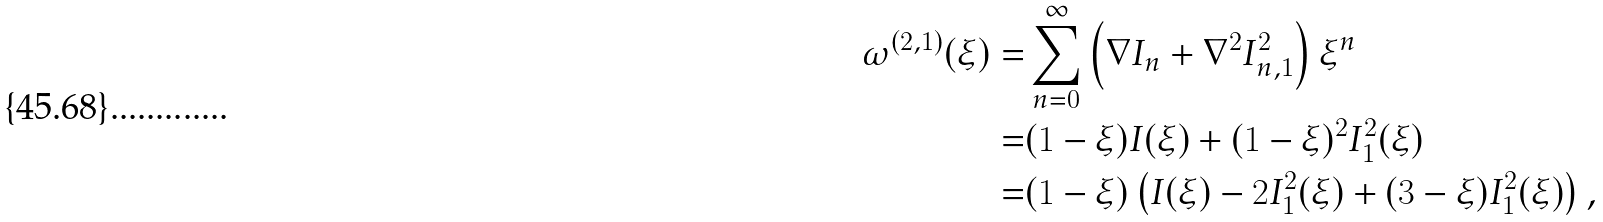Convert formula to latex. <formula><loc_0><loc_0><loc_500><loc_500>\omega ^ { ( 2 , 1 ) } ( \xi ) = & \sum _ { n = 0 } ^ { \infty } \left ( \nabla I _ { n } + \nabla ^ { 2 } I _ { n , 1 } ^ { 2 } \right ) \xi ^ { n } \\ = & ( 1 - \xi ) I ( \xi ) + ( 1 - \xi ) ^ { 2 } I _ { 1 } ^ { 2 } ( \xi ) \\ = & ( 1 - \xi ) \left ( I ( \xi ) - 2 I _ { 1 } ^ { 2 } ( \xi ) + ( 3 - \xi ) I _ { 1 } ^ { 2 } ( \xi ) \right ) ,</formula> 